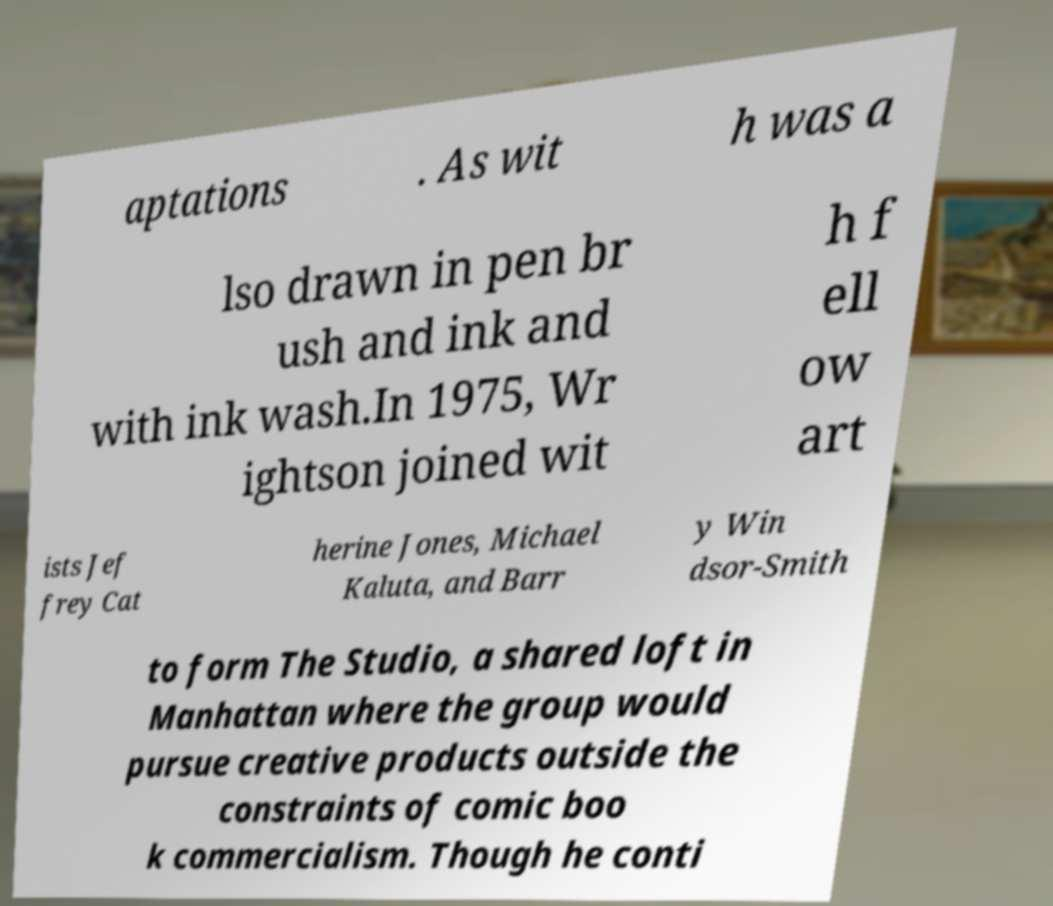I need the written content from this picture converted into text. Can you do that? aptations . As wit h was a lso drawn in pen br ush and ink and with ink wash.In 1975, Wr ightson joined wit h f ell ow art ists Jef frey Cat herine Jones, Michael Kaluta, and Barr y Win dsor-Smith to form The Studio, a shared loft in Manhattan where the group would pursue creative products outside the constraints of comic boo k commercialism. Though he conti 